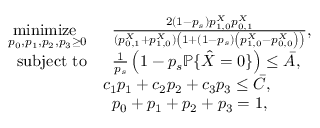<formula> <loc_0><loc_0><loc_500><loc_500>\begin{array} { r l } { \underset { p _ { 0 } , p _ { 1 } , p _ { 2 } , p _ { 3 } \geq 0 } { \min i m i z e } } & { \, \frac { 2 ( 1 - p _ { s } ) p _ { 1 , 0 } ^ { X } p _ { 0 , 1 } ^ { X } } { ( p _ { 0 , 1 } ^ { X } + p _ { 1 , 0 } ^ { X } ) \left ( 1 + ( 1 - p _ { s } ) \left ( p _ { 1 , 0 } ^ { X } - p _ { 0 , 0 } ^ { X } \right ) \right ) } , } \\ { s u b j e c t t o } & { \, \frac { 1 } { p _ { s } } \left ( 1 - p _ { s } \mathbb { P } \{ \hat { X } = 0 \} \right ) \leq \bar { A } , } \\ & { c _ { 1 } p _ { 1 } + c _ { 2 } p _ { 2 } + c _ { 3 } p _ { 3 } \leq \bar { C } , } \\ & { \, p _ { 0 } + p _ { 1 } + p _ { 2 } + p _ { 3 } = 1 , } \end{array}</formula> 